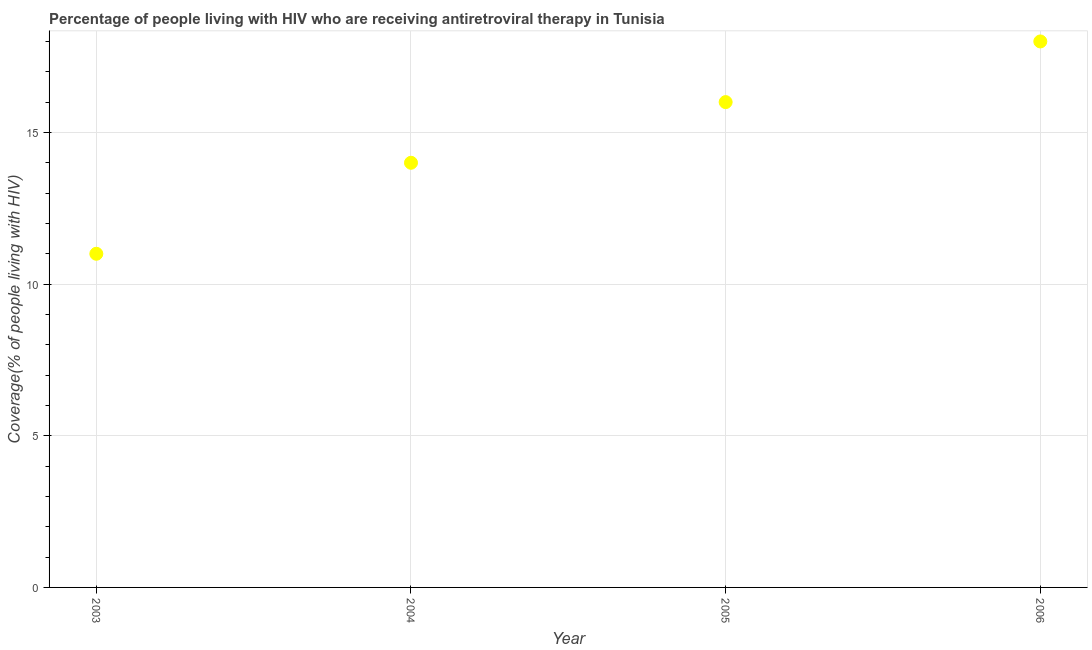What is the antiretroviral therapy coverage in 2004?
Offer a terse response. 14. Across all years, what is the maximum antiretroviral therapy coverage?
Ensure brevity in your answer.  18. Across all years, what is the minimum antiretroviral therapy coverage?
Keep it short and to the point. 11. In which year was the antiretroviral therapy coverage minimum?
Your answer should be compact. 2003. What is the sum of the antiretroviral therapy coverage?
Provide a succinct answer. 59. What is the difference between the antiretroviral therapy coverage in 2003 and 2005?
Give a very brief answer. -5. What is the average antiretroviral therapy coverage per year?
Provide a short and direct response. 14.75. In how many years, is the antiretroviral therapy coverage greater than 16 %?
Offer a very short reply. 1. What is the ratio of the antiretroviral therapy coverage in 2003 to that in 2006?
Provide a short and direct response. 0.61. Is the antiretroviral therapy coverage in 2003 less than that in 2004?
Your response must be concise. Yes. Is the difference between the antiretroviral therapy coverage in 2003 and 2004 greater than the difference between any two years?
Offer a terse response. No. What is the difference between the highest and the second highest antiretroviral therapy coverage?
Ensure brevity in your answer.  2. What is the difference between the highest and the lowest antiretroviral therapy coverage?
Give a very brief answer. 7. In how many years, is the antiretroviral therapy coverage greater than the average antiretroviral therapy coverage taken over all years?
Offer a very short reply. 2. What is the title of the graph?
Ensure brevity in your answer.  Percentage of people living with HIV who are receiving antiretroviral therapy in Tunisia. What is the label or title of the X-axis?
Offer a very short reply. Year. What is the label or title of the Y-axis?
Provide a succinct answer. Coverage(% of people living with HIV). What is the Coverage(% of people living with HIV) in 2004?
Your answer should be very brief. 14. What is the Coverage(% of people living with HIV) in 2005?
Offer a terse response. 16. What is the difference between the Coverage(% of people living with HIV) in 2003 and 2004?
Your response must be concise. -3. What is the difference between the Coverage(% of people living with HIV) in 2003 and 2005?
Provide a short and direct response. -5. What is the difference between the Coverage(% of people living with HIV) in 2004 and 2006?
Keep it short and to the point. -4. What is the difference between the Coverage(% of people living with HIV) in 2005 and 2006?
Your answer should be very brief. -2. What is the ratio of the Coverage(% of people living with HIV) in 2003 to that in 2004?
Provide a short and direct response. 0.79. What is the ratio of the Coverage(% of people living with HIV) in 2003 to that in 2005?
Make the answer very short. 0.69. What is the ratio of the Coverage(% of people living with HIV) in 2003 to that in 2006?
Offer a very short reply. 0.61. What is the ratio of the Coverage(% of people living with HIV) in 2004 to that in 2005?
Your answer should be very brief. 0.88. What is the ratio of the Coverage(% of people living with HIV) in 2004 to that in 2006?
Keep it short and to the point. 0.78. What is the ratio of the Coverage(% of people living with HIV) in 2005 to that in 2006?
Provide a short and direct response. 0.89. 